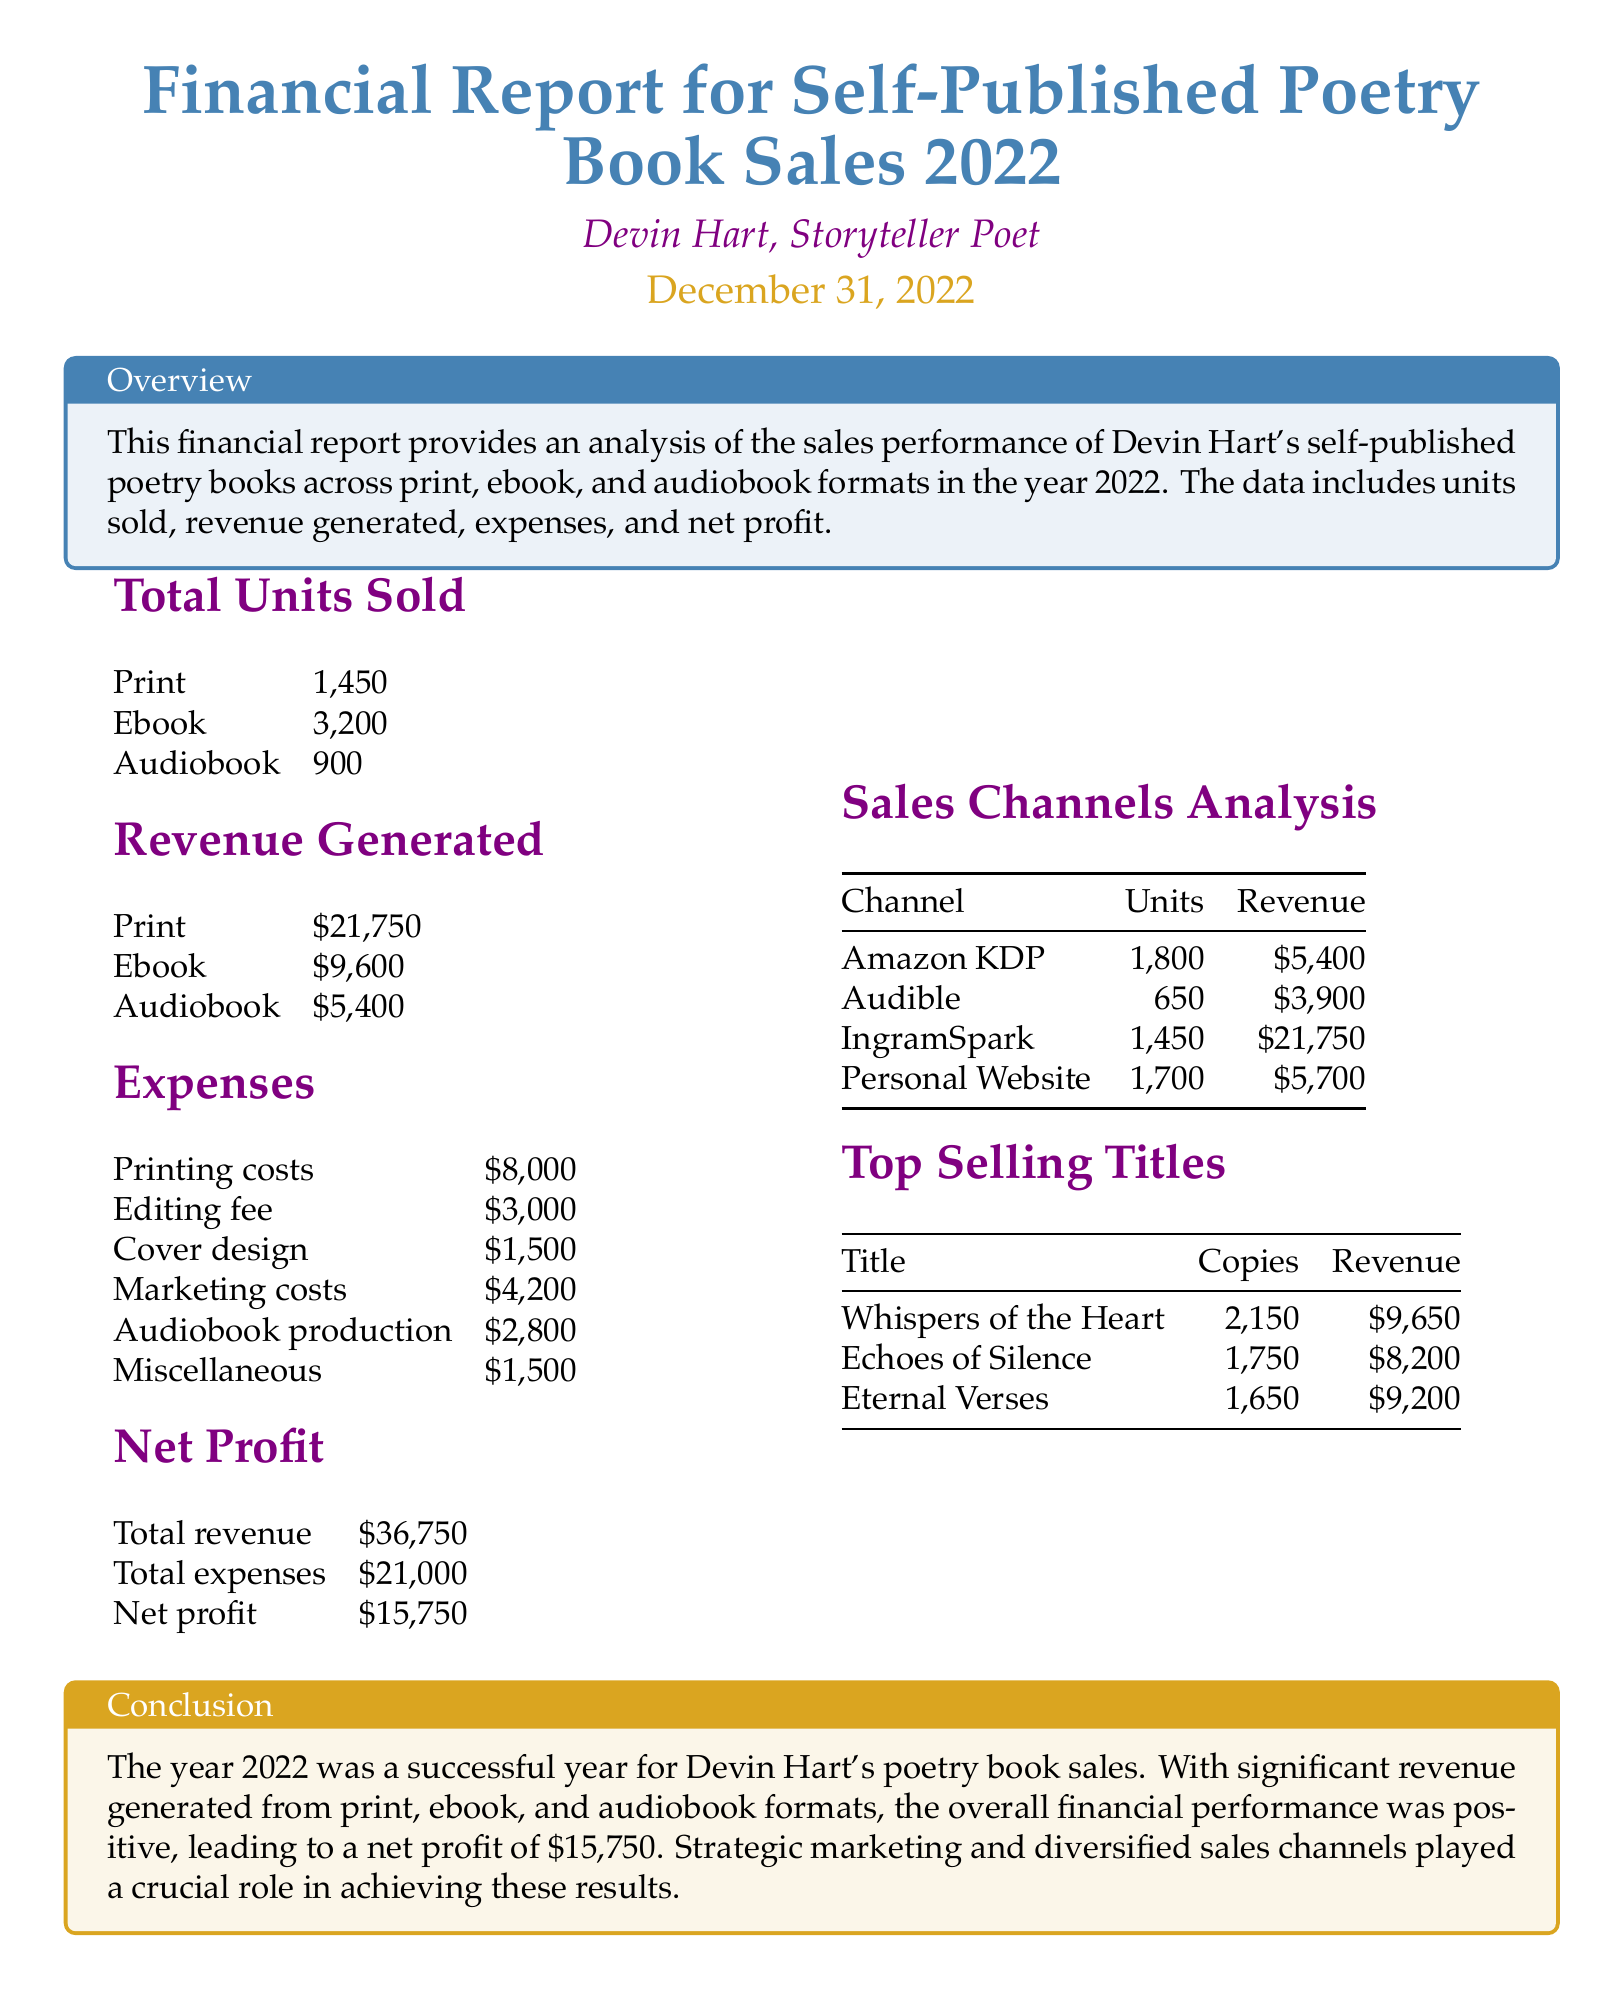What is the total net profit? The total net profit is presented in the financial report, clearly stated at the bottom of the NET PROFIT section.
Answer: $15,750 How many copies of "Whispers of the Heart" were sold? The copies sold of "Whispers of the Heart" is listed in the Top Selling Titles section, indicating its popularity among readers.
Answer: 2,150 What is the revenue generated from ebook sales? The revenue generated from ebook sales is documented in the Revenue Generated section and reflects the financial success of this format.
Answer: $9,600 What were the total expenses? The total expenses is specified in the NET PROFIT section, highlighting the costs incurred during the sales process.
Answer: $21,000 Which sales channel generated the most revenue? By analyzing the Sales Channels Analysis section, we can determine which channel was the most successful in terms of revenue generation.
Answer: IngramSpark 